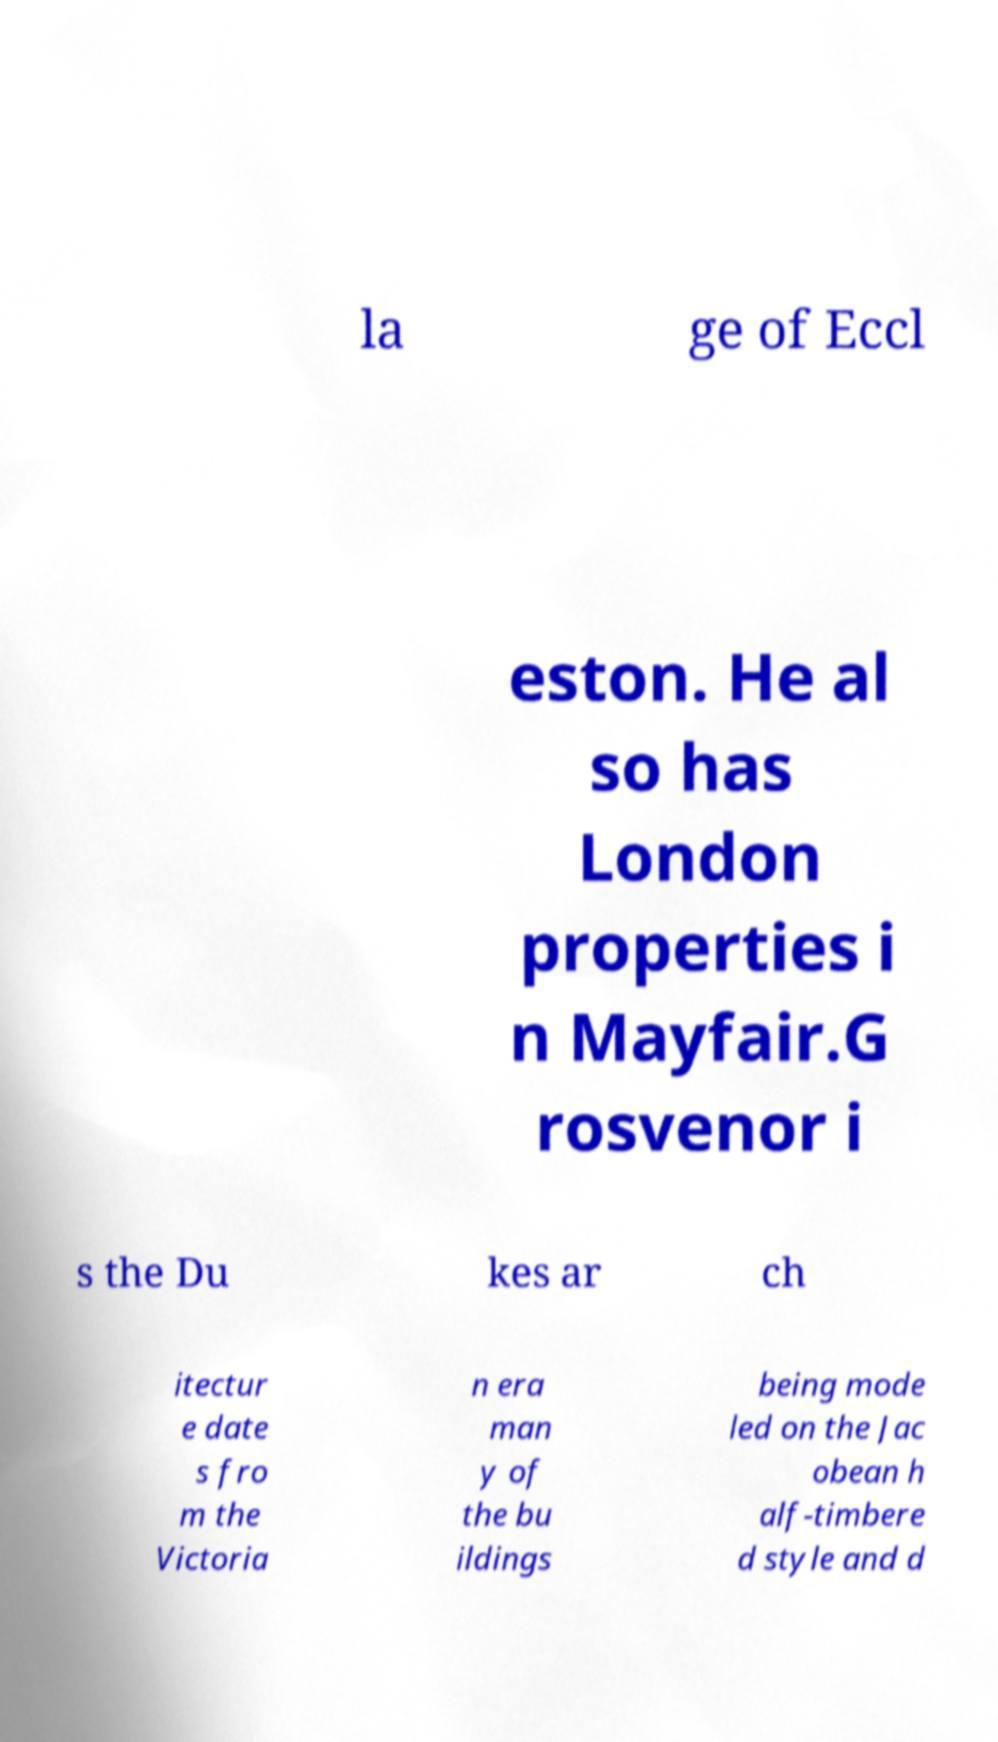Please identify and transcribe the text found in this image. la ge of Eccl eston. He al so has London properties i n Mayfair.G rosvenor i s the Du kes ar ch itectur e date s fro m the Victoria n era man y of the bu ildings being mode led on the Jac obean h alf-timbere d style and d 